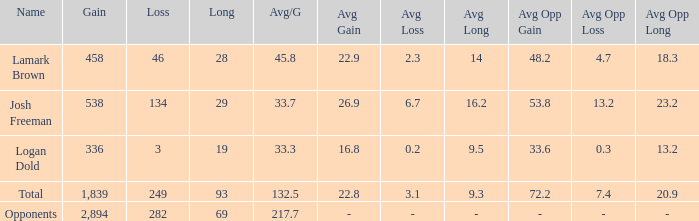Which Long is the highest one that has a Loss larger than 3, and a Gain larger than 2,894? None. 